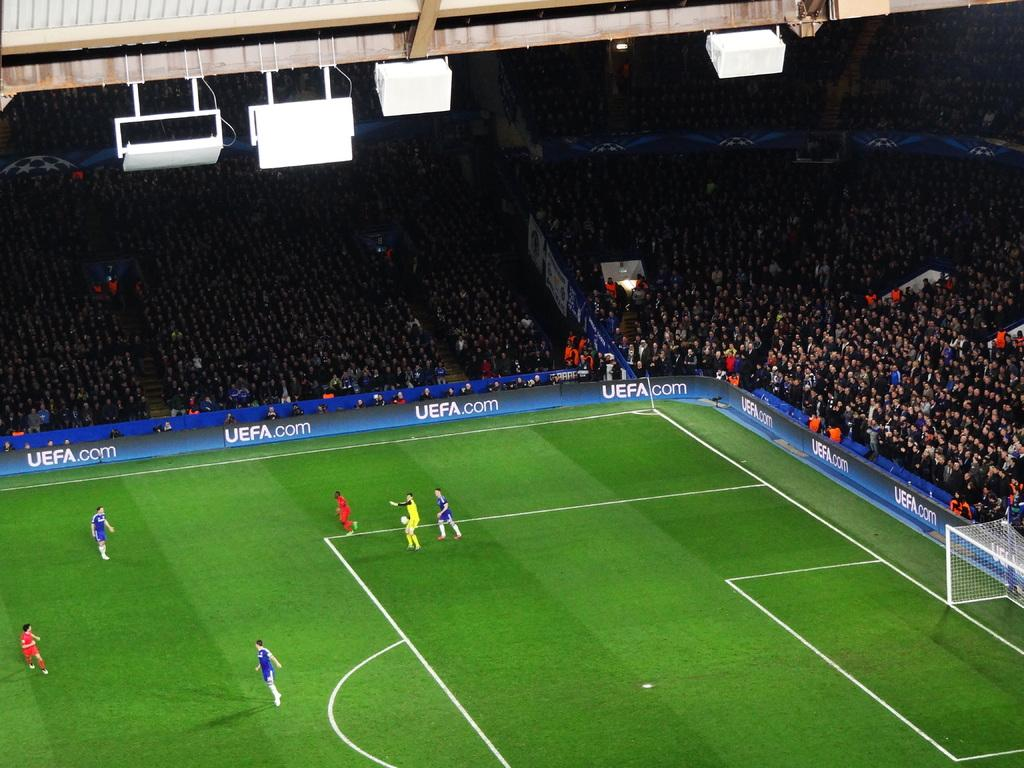Provide a one-sentence caption for the provided image. A website address for the UEFA is featured around the perimeter of a green grassy soccer field. 